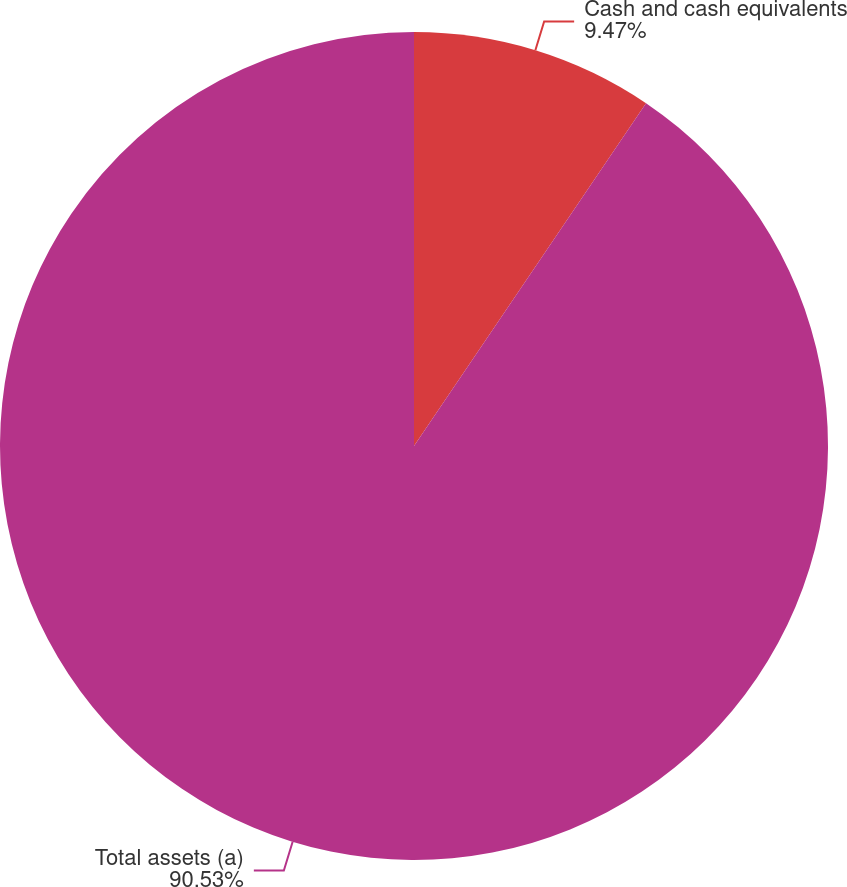Convert chart. <chart><loc_0><loc_0><loc_500><loc_500><pie_chart><fcel>Cash and cash equivalents<fcel>Total assets (a)<nl><fcel>9.47%<fcel>90.53%<nl></chart> 